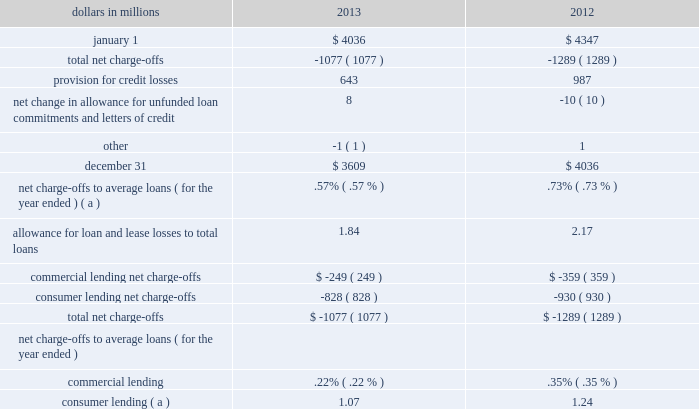Table 46 : allowance for loan and lease losses .
( a ) includes charge-offs of $ 134 million taken pursuant to alignment with interagency guidance on practices for loans and lines of credit related to consumer lending in the first quarter of 2013 .
The provision for credit losses totaled $ 643 million for 2013 compared to $ 987 million for 2012 .
The primary driver of the decrease to the provision was improved overall credit quality , including improved commercial loan risk factors , lower consumer loan delinquencies and improvements in expected cash flows for our purchased impaired loans .
For 2013 , the provision for commercial lending credit losses decreased by $ 102 million , or 74% ( 74 % ) , from 2012 .
The provision for consumer lending credit losses decreased $ 242 million , or 29% ( 29 % ) , from 2012 .
At december 31 , 2013 , total alll to total nonperforming loans was 117% ( 117 % ) .
The comparable amount for december 31 , 2012 was 124% ( 124 % ) .
These ratios are 72% ( 72 % ) and 79% ( 79 % ) , respectively , when excluding the $ 1.4 billion and $ 1.5 billion , respectively , of alll at december 31 , 2013 and december 31 , 2012 allocated to consumer loans and lines of credit not secured by residential real estate and purchased impaired loans .
We have excluded consumer loans and lines of credit not secured by real estate as they are charged off after 120 to 180 days past due and not placed on nonperforming status .
Additionally , we have excluded purchased impaired loans as they are considered performing regardless of their delinquency status as interest is accreted based on our estimate of expected cash flows and additional allowance is recorded when these cash flows are below recorded investment .
See table 35 within this credit risk management section for additional information .
The alll balance increases or decreases across periods in relation to fluctuating risk factors , including asset quality trends , charge-offs and changes in aggregate portfolio balances .
During 2013 , improving asset quality trends , including , but not limited to , delinquency status and improving economic conditions , realization of previously estimated losses through charge-offs , including the impact of alignment with interagency guidance and overall portfolio growth , combined to result in the alll balance declining $ .4 billion , or 11% ( 11 % ) to $ 3.6 billion as of december 31 , 2013 compared to december 31 , 2012 .
See note 7 allowances for loan and lease losses and unfunded loan commitments and letters of credit and note 6 purchased loans in the notes to consolidated financial statements in item 8 of this report regarding changes in the alll and in the allowance for unfunded loan commitments and letters of credit .
Operational risk management operational risk is the risk of loss resulting from inadequate or failed internal processes or systems , human factors , or external events .
This includes losses that may arise as a result of non- compliance with laws or regulations , failure to fulfill fiduciary responsibilities , as well as litigation or other legal actions .
Operational risk may occur in any of our business activities and manifests itself in various ways , including but not limited to : 2022 transaction processing errors , 2022 unauthorized transactions and fraud by employees or third parties , 2022 material disruption in business activities , 2022 system breaches and misuse of sensitive information , 2022 regulatory or governmental actions , fines or penalties , and 2022 significant legal expenses , judgments or settlements .
Pnc 2019s operational risk management is inclusive of technology risk management , compliance and business continuity risk .
Operational risk management focuses on balancing business needs , regulatory expectations and risk management priorities through an adaptive and proactive program that is designed to provide a strong governance model , sound and consistent risk management processes and transparent operational risk reporting across the enterprise .
The pnc board determines the strategic approach to operational risk via establishment of the operational risk appetite and appropriate risk management structure .
This includes establishment of risk metrics and limits and a reporting structure to identify , understand and manage operational risks .
Executive management has responsibility for operational risk management .
The executive management team is responsible for monitoring significant risks , key controls and related issues through management reporting and a governance structure of risk committees and sub-committees .
Within risk management , operational risk management functions are responsible for developing and maintaining the 84 the pnc financial services group , inc .
2013 form 10-k .
What was the percentage change in the allowance for loan and lease losses from 2012 to 2013? 
Computations: ((3609 - 4036) / 4036)
Answer: -0.1058. 